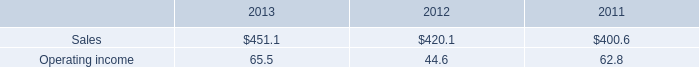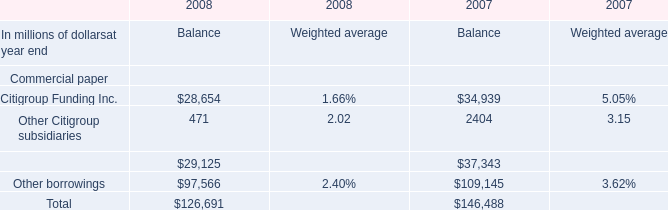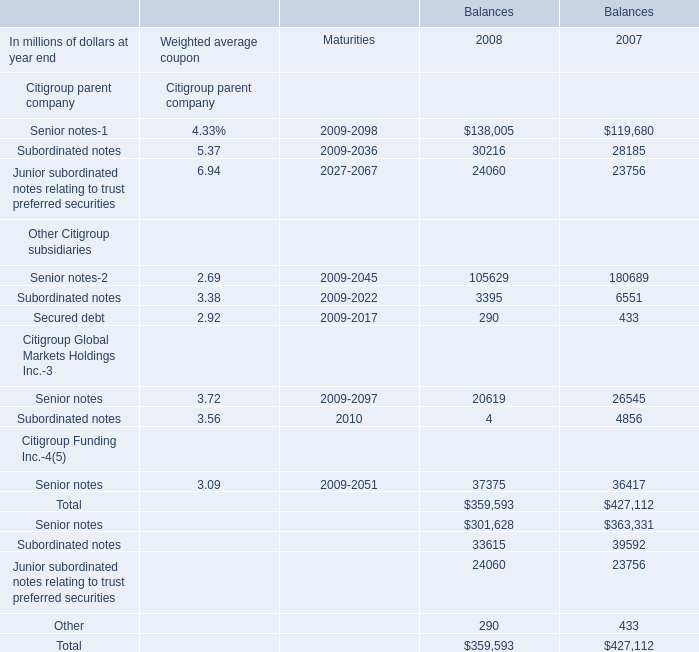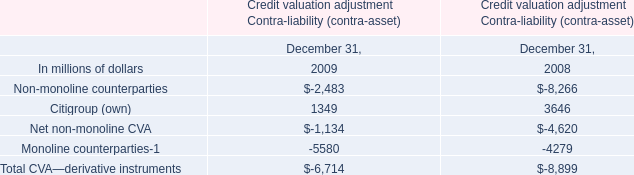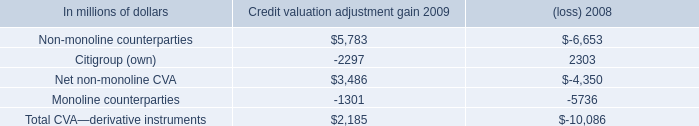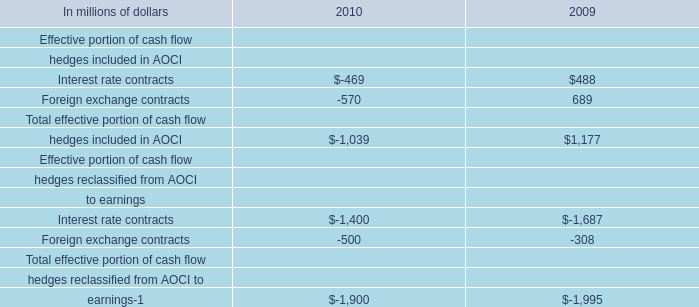What's the sum of Interest rate contracts to earnings of 2010, and Subordinated notes Other Citigroup subsidiaries of Balances 2008 ? 
Computations: (1400.0 + 3395.0)
Answer: 4795.0. 